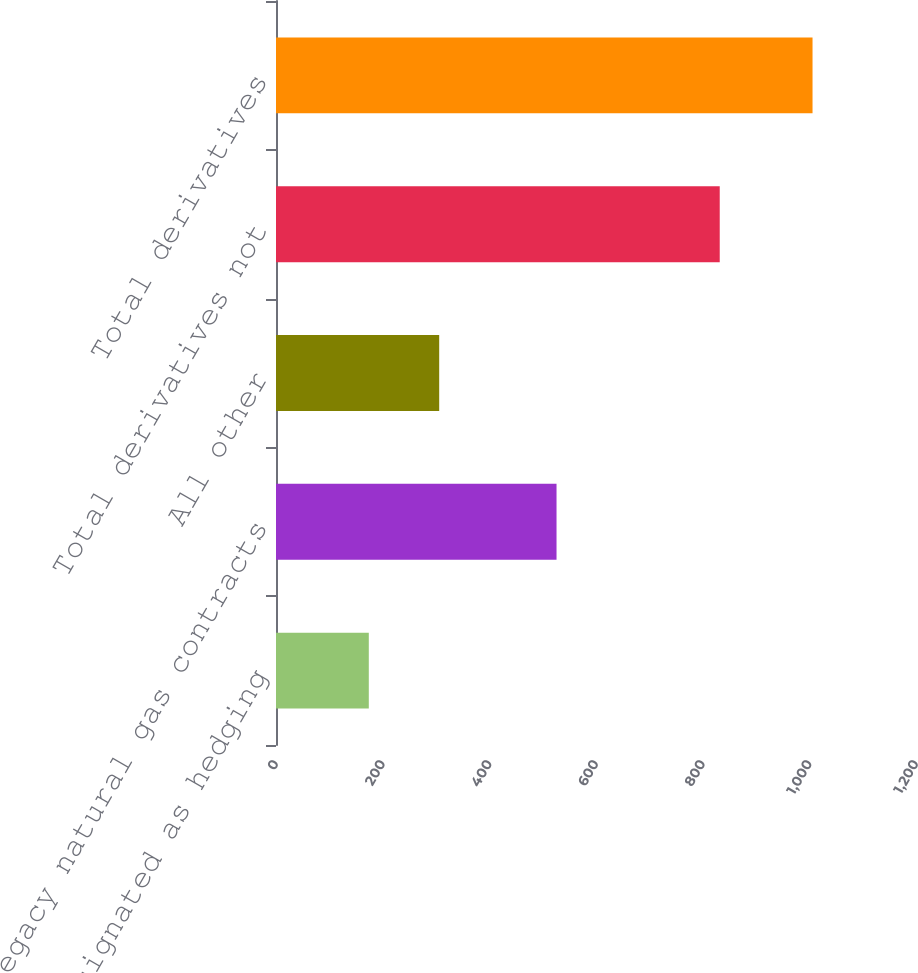Convert chart. <chart><loc_0><loc_0><loc_500><loc_500><bar_chart><fcel>Designated as hedging<fcel>Legacy natural gas contracts<fcel>All other<fcel>Total derivatives not<fcel>Total derivatives<nl><fcel>174<fcel>526<fcel>306<fcel>832<fcel>1006<nl></chart> 